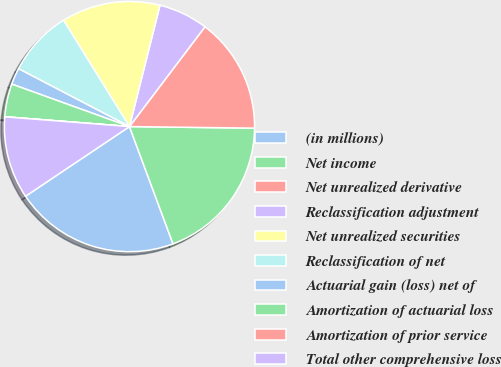Convert chart to OTSL. <chart><loc_0><loc_0><loc_500><loc_500><pie_chart><fcel>(in millions)<fcel>Net income<fcel>Net unrealized derivative<fcel>Reclassification adjustment<fcel>Net unrealized securities<fcel>Reclassification of net<fcel>Actuarial gain (loss) net of<fcel>Amortization of actuarial loss<fcel>Amortization of prior service<fcel>Total other comprehensive loss<nl><fcel>21.26%<fcel>19.14%<fcel>14.89%<fcel>6.39%<fcel>12.76%<fcel>8.51%<fcel>2.14%<fcel>4.26%<fcel>0.01%<fcel>10.64%<nl></chart> 